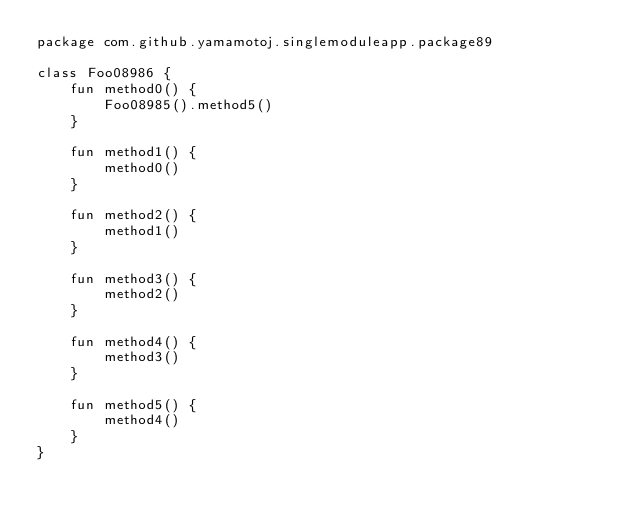<code> <loc_0><loc_0><loc_500><loc_500><_Kotlin_>package com.github.yamamotoj.singlemoduleapp.package89

class Foo08986 {
    fun method0() {
        Foo08985().method5()
    }

    fun method1() {
        method0()
    }

    fun method2() {
        method1()
    }

    fun method3() {
        method2()
    }

    fun method4() {
        method3()
    }

    fun method5() {
        method4()
    }
}
</code> 